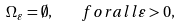<formula> <loc_0><loc_0><loc_500><loc_500>\Omega _ { \varepsilon } = \emptyset , \quad f o r a l l \varepsilon > 0 ,</formula> 